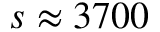<formula> <loc_0><loc_0><loc_500><loc_500>s \approx 3 7 0 0</formula> 